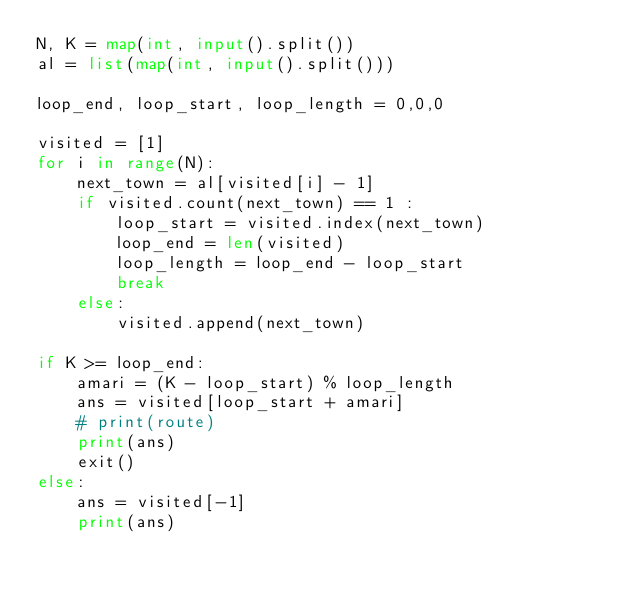Convert code to text. <code><loc_0><loc_0><loc_500><loc_500><_Python_>N, K = map(int, input().split())
al = list(map(int, input().split()))

loop_end, loop_start, loop_length = 0,0,0

visited = [1]
for i in range(N):
    next_town = al[visited[i] - 1]
    if visited.count(next_town) == 1 :
        loop_start = visited.index(next_town)
        loop_end = len(visited)
        loop_length = loop_end - loop_start
        break
    else:
        visited.append(next_town)

if K >= loop_end:
    amari = (K - loop_start) % loop_length
    ans = visited[loop_start + amari]
    # print(route)
    print(ans)
    exit()
else:
    ans = visited[-1]
    print(ans)
</code> 